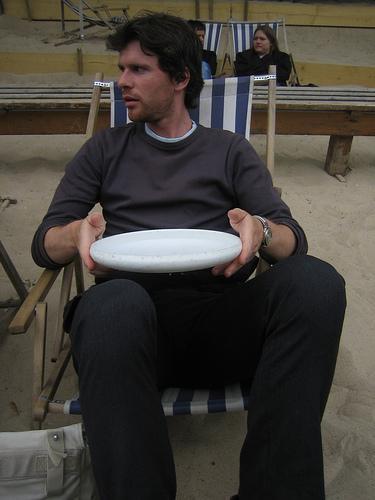What outdoor activity has the man taken a break from?
Select the accurate answer and provide explanation: 'Answer: answer
Rationale: rationale.'
Options: Baseball, basketball, frisbee, racing. Answer: frisbee.
Rationale: The man is sitting in a chair and holding a plastic disk in his hands which is what is used to play the game. 